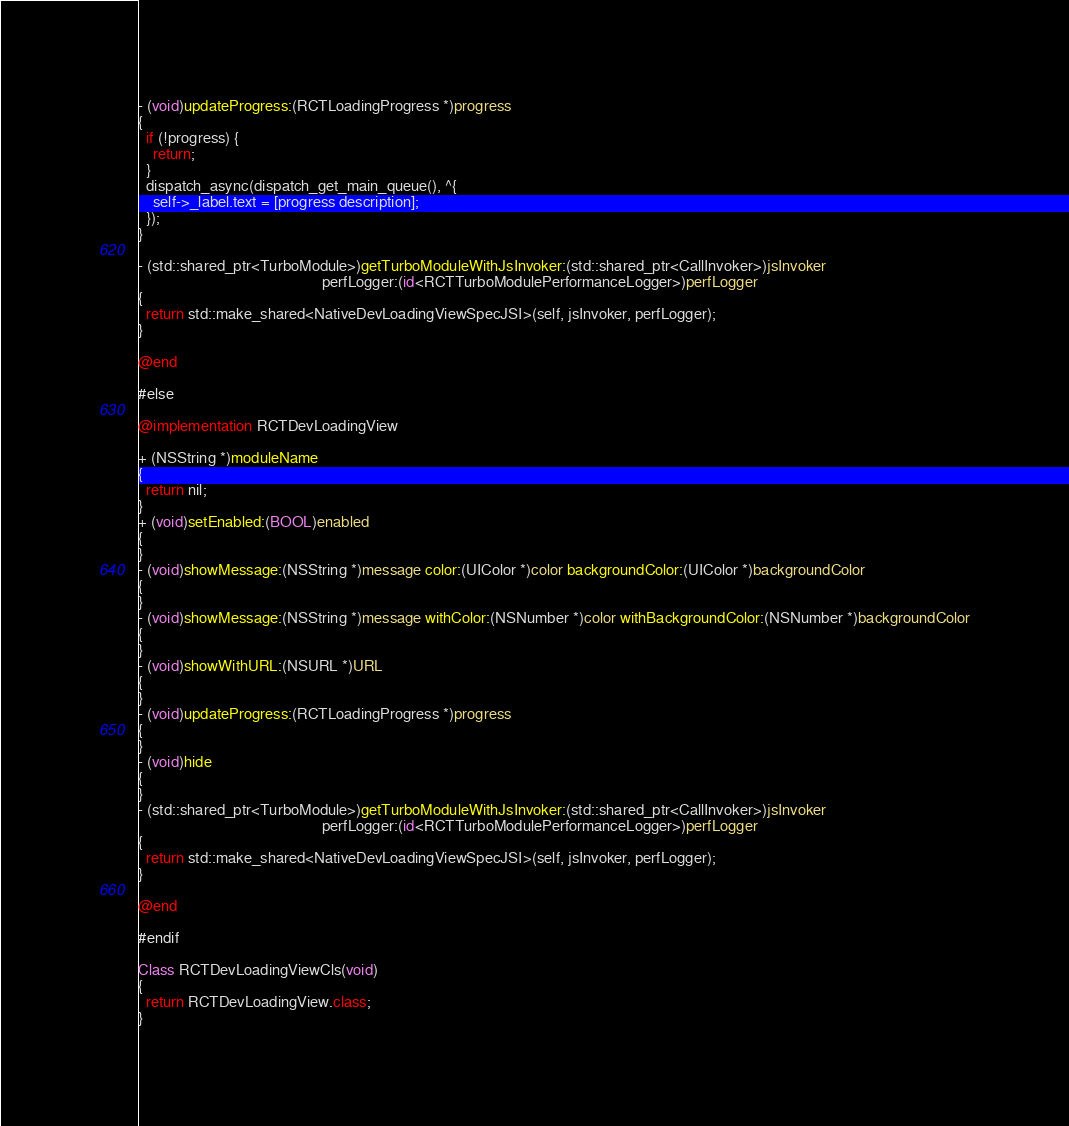<code> <loc_0><loc_0><loc_500><loc_500><_ObjectiveC_>- (void)updateProgress:(RCTLoadingProgress *)progress
{
  if (!progress) {
    return;
  }
  dispatch_async(dispatch_get_main_queue(), ^{
    self->_label.text = [progress description];
  });
}

- (std::shared_ptr<TurboModule>)getTurboModuleWithJsInvoker:(std::shared_ptr<CallInvoker>)jsInvoker
                                                 perfLogger:(id<RCTTurboModulePerformanceLogger>)perfLogger
{
  return std::make_shared<NativeDevLoadingViewSpecJSI>(self, jsInvoker, perfLogger);
}

@end

#else

@implementation RCTDevLoadingView

+ (NSString *)moduleName
{
  return nil;
}
+ (void)setEnabled:(BOOL)enabled
{
}
- (void)showMessage:(NSString *)message color:(UIColor *)color backgroundColor:(UIColor *)backgroundColor
{
}
- (void)showMessage:(NSString *)message withColor:(NSNumber *)color withBackgroundColor:(NSNumber *)backgroundColor
{
}
- (void)showWithURL:(NSURL *)URL
{
}
- (void)updateProgress:(RCTLoadingProgress *)progress
{
}
- (void)hide
{
}
- (std::shared_ptr<TurboModule>)getTurboModuleWithJsInvoker:(std::shared_ptr<CallInvoker>)jsInvoker
                                                 perfLogger:(id<RCTTurboModulePerformanceLogger>)perfLogger
{
  return std::make_shared<NativeDevLoadingViewSpecJSI>(self, jsInvoker, perfLogger);
}

@end

#endif

Class RCTDevLoadingViewCls(void)
{
  return RCTDevLoadingView.class;
}
</code> 